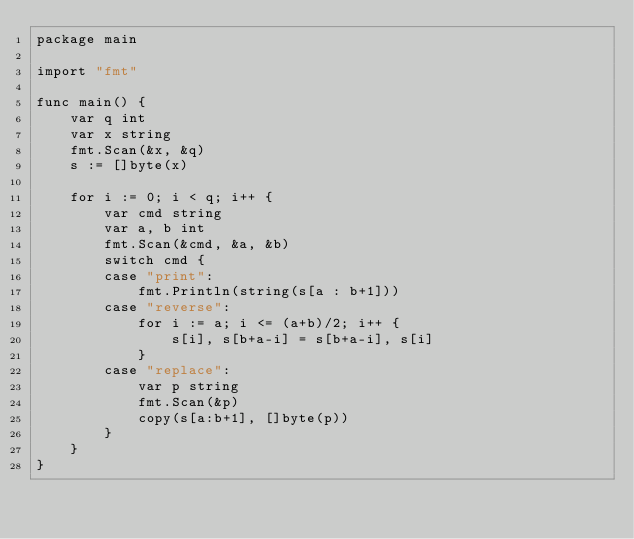<code> <loc_0><loc_0><loc_500><loc_500><_Go_>package main

import "fmt"

func main() {
	var q int
	var x string
	fmt.Scan(&x, &q)
	s := []byte(x)

	for i := 0; i < q; i++ {
		var cmd string
		var a, b int
		fmt.Scan(&cmd, &a, &b)
		switch cmd {
		case "print":
			fmt.Println(string(s[a : b+1]))
		case "reverse":
			for i := a; i <= (a+b)/2; i++ {
				s[i], s[b+a-i] = s[b+a-i], s[i]
			}
		case "replace":
			var p string
			fmt.Scan(&p)
			copy(s[a:b+1], []byte(p))
		}
	}
}

</code> 